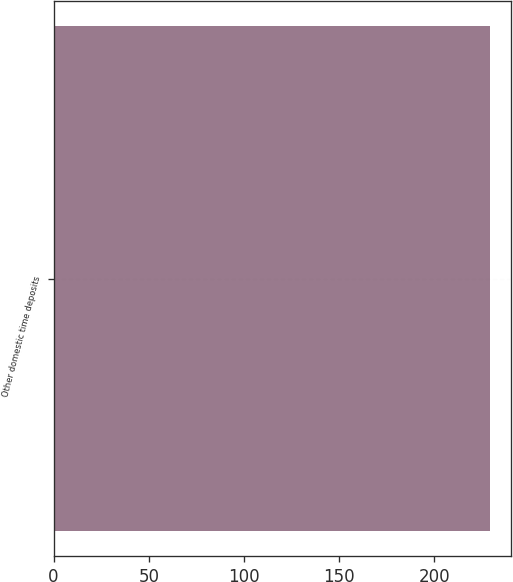Convert chart to OTSL. <chart><loc_0><loc_0><loc_500><loc_500><bar_chart><fcel>Other domestic time deposits<nl><fcel>229<nl></chart> 